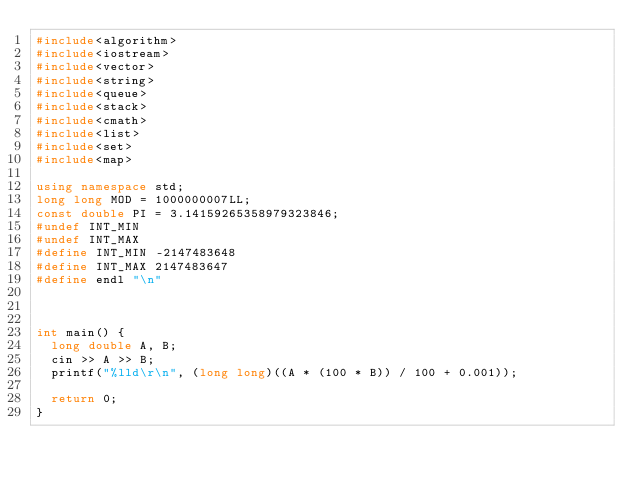<code> <loc_0><loc_0><loc_500><loc_500><_C++_>#include<algorithm>
#include<iostream>
#include<vector>
#include<string>
#include<queue>
#include<stack>
#include<cmath>
#include<list>
#include<set>
#include<map>

using namespace std;
long long MOD = 1000000007LL;
const double PI = 3.14159265358979323846;
#undef INT_MIN
#undef INT_MAX
#define INT_MIN -2147483648
#define INT_MAX 2147483647
#define endl "\n"



int main() {
	long double A, B;
	cin >> A >> B;
	printf("%lld\r\n", (long long)((A * (100 * B)) / 100 + 0.001));

	return 0;
}


</code> 